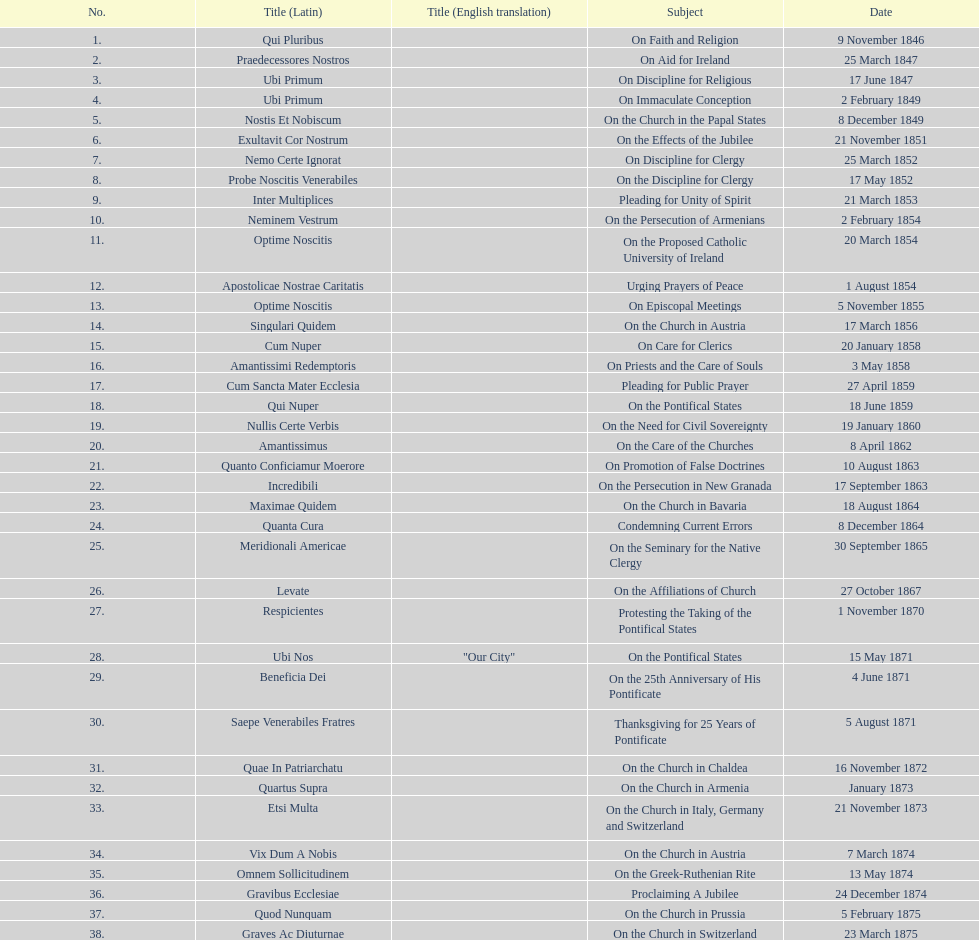How many different subjects exist? 38. 